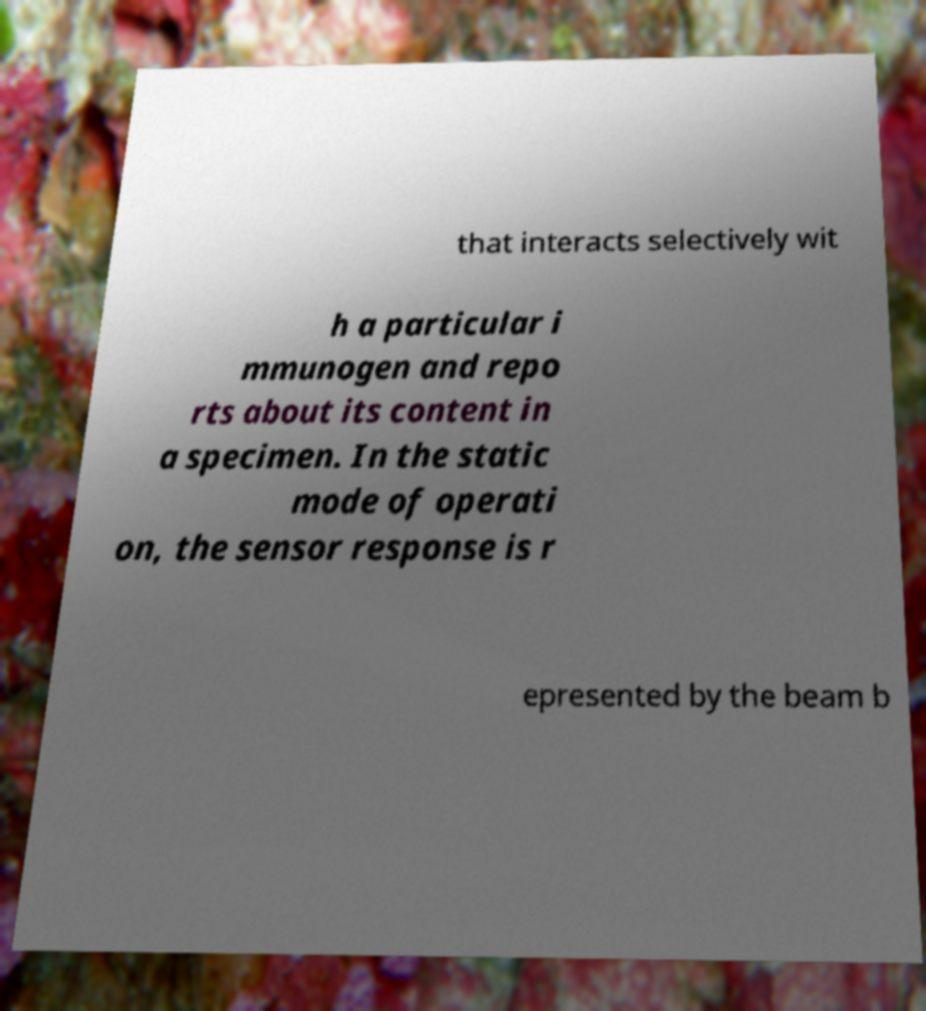For documentation purposes, I need the text within this image transcribed. Could you provide that? that interacts selectively wit h a particular i mmunogen and repo rts about its content in a specimen. In the static mode of operati on, the sensor response is r epresented by the beam b 